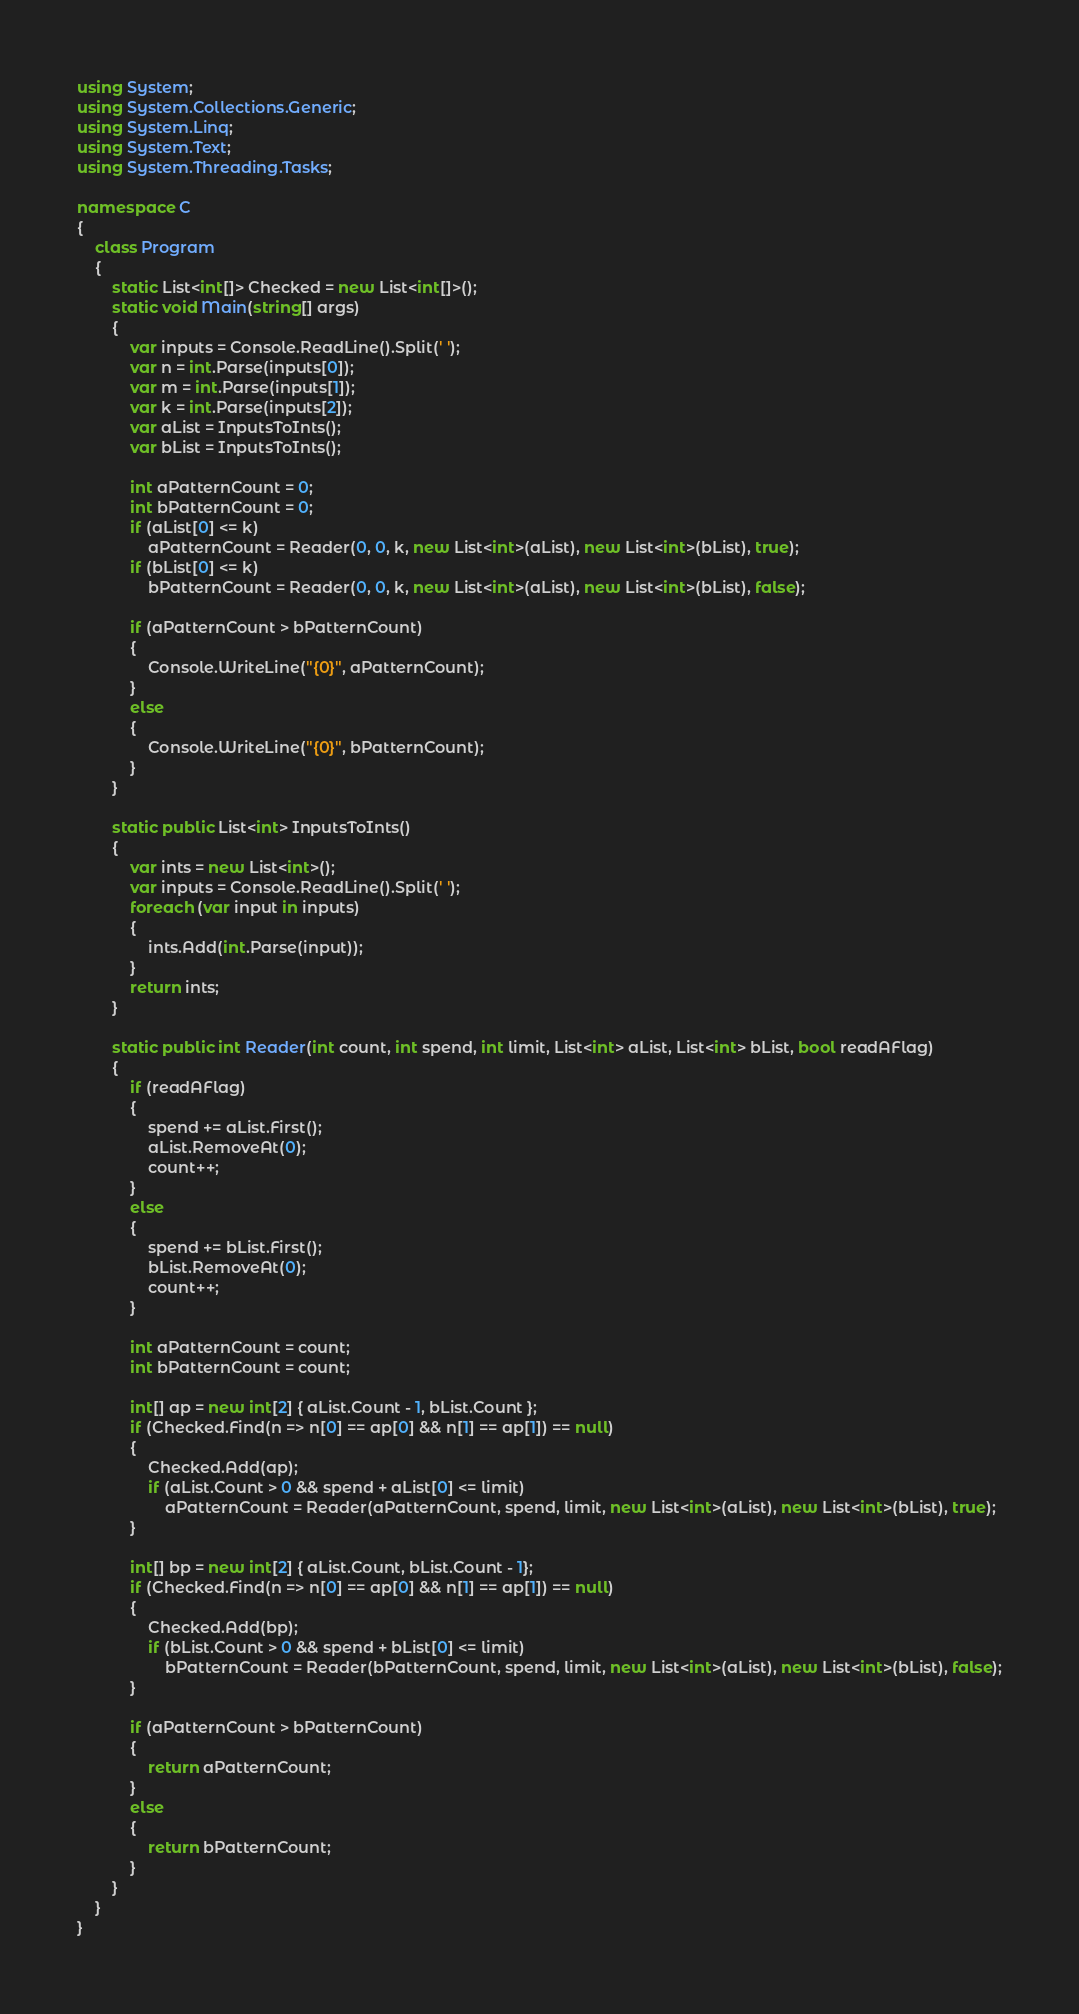Convert code to text. <code><loc_0><loc_0><loc_500><loc_500><_C#_>using System;
using System.Collections.Generic;
using System.Linq;
using System.Text;
using System.Threading.Tasks;

namespace C
{
    class Program
    {
        static List<int[]> Checked = new List<int[]>();
        static void Main(string[] args)
        {
            var inputs = Console.ReadLine().Split(' ');
            var n = int.Parse(inputs[0]);
            var m = int.Parse(inputs[1]);
            var k = int.Parse(inputs[2]);
            var aList = InputsToInts();
            var bList = InputsToInts();

            int aPatternCount = 0;
            int bPatternCount = 0;
            if (aList[0] <= k)
                aPatternCount = Reader(0, 0, k, new List<int>(aList), new List<int>(bList), true);
            if (bList[0] <= k)
                bPatternCount = Reader(0, 0, k, new List<int>(aList), new List<int>(bList), false);

            if (aPatternCount > bPatternCount)
            {
                Console.WriteLine("{0}", aPatternCount);
            }
            else
            {
                Console.WriteLine("{0}", bPatternCount);
            }
        }

        static public List<int> InputsToInts()
        {
            var ints = new List<int>();
            var inputs = Console.ReadLine().Split(' ');
            foreach (var input in inputs)
            {
                ints.Add(int.Parse(input));
            }
            return ints;
        }

        static public int Reader(int count, int spend, int limit, List<int> aList, List<int> bList, bool readAFlag)
        {
            if (readAFlag)
            {
                spend += aList.First();
                aList.RemoveAt(0);
                count++;
            }
            else
            {
                spend += bList.First();
                bList.RemoveAt(0);
                count++;
            }

            int aPatternCount = count;
            int bPatternCount = count;

            int[] ap = new int[2] { aList.Count - 1, bList.Count };
            if (Checked.Find(n => n[0] == ap[0] && n[1] == ap[1]) == null)
            {
                Checked.Add(ap);
                if (aList.Count > 0 && spend + aList[0] <= limit)
                    aPatternCount = Reader(aPatternCount, spend, limit, new List<int>(aList), new List<int>(bList), true);
            }

            int[] bp = new int[2] { aList.Count, bList.Count - 1};
            if (Checked.Find(n => n[0] == ap[0] && n[1] == ap[1]) == null)
            {
                Checked.Add(bp);
                if (bList.Count > 0 && spend + bList[0] <= limit)
                    bPatternCount = Reader(bPatternCount, spend, limit, new List<int>(aList), new List<int>(bList), false);
            }

            if (aPatternCount > bPatternCount)
            {
                return aPatternCount;
            }
            else
            {
                return bPatternCount;
            }
        }
    }
}
</code> 